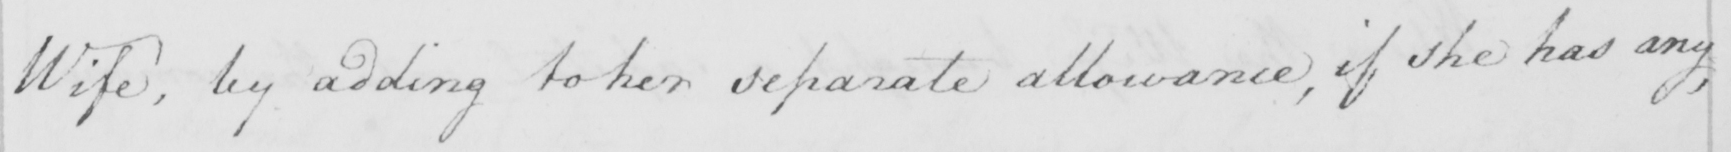What is written in this line of handwriting? Wife , by addingto her separate allowance , if she has any , 